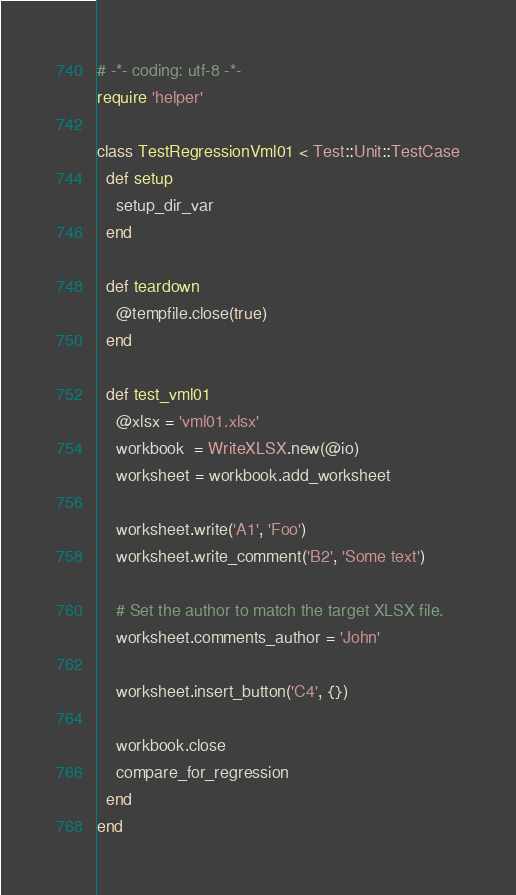Convert code to text. <code><loc_0><loc_0><loc_500><loc_500><_Ruby_># -*- coding: utf-8 -*-
require 'helper'

class TestRegressionVml01 < Test::Unit::TestCase
  def setup
    setup_dir_var
  end

  def teardown
    @tempfile.close(true)
  end

  def test_vml01
    @xlsx = 'vml01.xlsx'
    workbook  = WriteXLSX.new(@io)
    worksheet = workbook.add_worksheet

    worksheet.write('A1', 'Foo')
    worksheet.write_comment('B2', 'Some text')

    # Set the author to match the target XLSX file.
    worksheet.comments_author = 'John'

    worksheet.insert_button('C4', {})

    workbook.close
    compare_for_regression
  end
end
</code> 